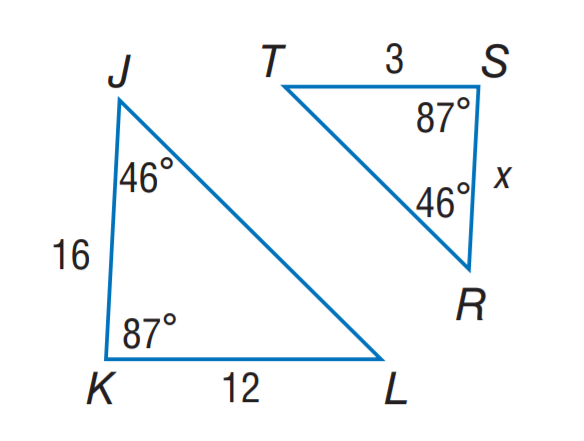Answer the mathemtical geometry problem and directly provide the correct option letter.
Question: Find S R.
Choices: A: 3 B: 4 C: 5 D: 6 B 